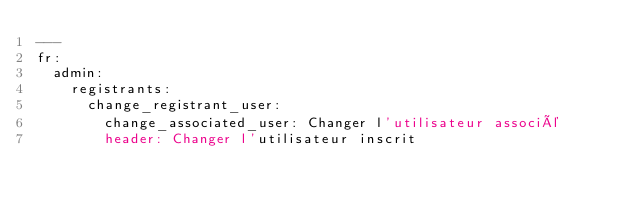Convert code to text. <code><loc_0><loc_0><loc_500><loc_500><_YAML_>---
fr:
  admin:
    registrants:
      change_registrant_user:
        change_associated_user: Changer l'utilisateur associé
        header: Changer l'utilisateur inscrit
</code> 